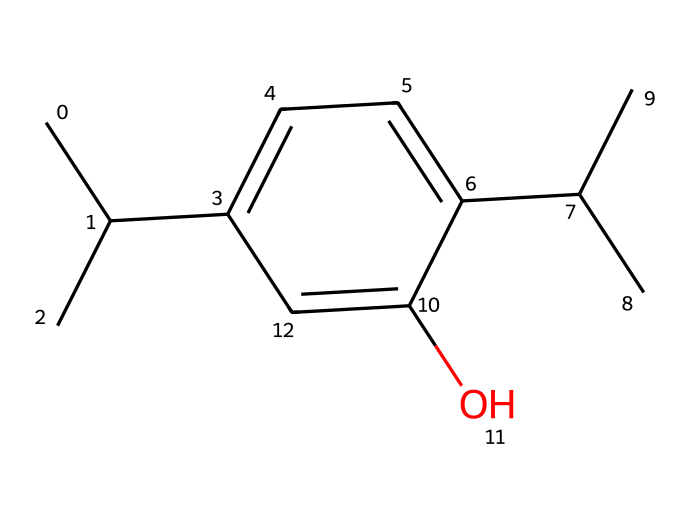what is the molecular formula of thymol? The molecular formula can be derived from counting the atoms represented in the structure. The SMILES indicates there are 10 carbon (C) atoms, 14 hydrogen (H) atoms, and 1 oxygen (O) atom. Thus, the molecular formula is C10H14O.
Answer: C10H14O how many aromatic rings are present in the structure? The structure indicates that there is one distinct aromatic ring, which can be identified by the alternating double bonds in the ring portion of the SMILES. Thus, there is one aromatic ring.
Answer: one which functional group is present in thymol? An analysis of the structure shows the presence of a hydroxyl (–OH) group attached to the aromatic ring, which classifies as a functional group. Therefore, the functional group is a phenolic hydroxyl group.
Answer: phenolic hydroxyl what is the primary role of thymol as a fungicide? Thymol functions primarily by disrupting the cell membranes of fungi, leading to cell lysis and death. This mechanism makes it an effective fungicide.
Answer: disrupts cell membranes how does the structure of thymol contribute to its antifungal properties? The presence of multiple carbon atoms and an aromatic ring in the structure contributes to its lipophilicity, allowing it to penetrate cell membranes of fungi easily. This penetration is essential for its antifungal activity.
Answer: lipophilicity what is the significance of the chiral center in thymol? The presence of a chiral center affects the orientation of the molecule, impacting its interaction with fungal enzymes or receptors, which can enhance its effectiveness as a fungicide.
Answer: affects biological interactions how many stereoisomers are possible for thymol? The presence of one chiral center in thymol suggests that there can be 2 stereoisomers, since each chiral center generates two possibilities for spatial arrangement.
Answer: two 